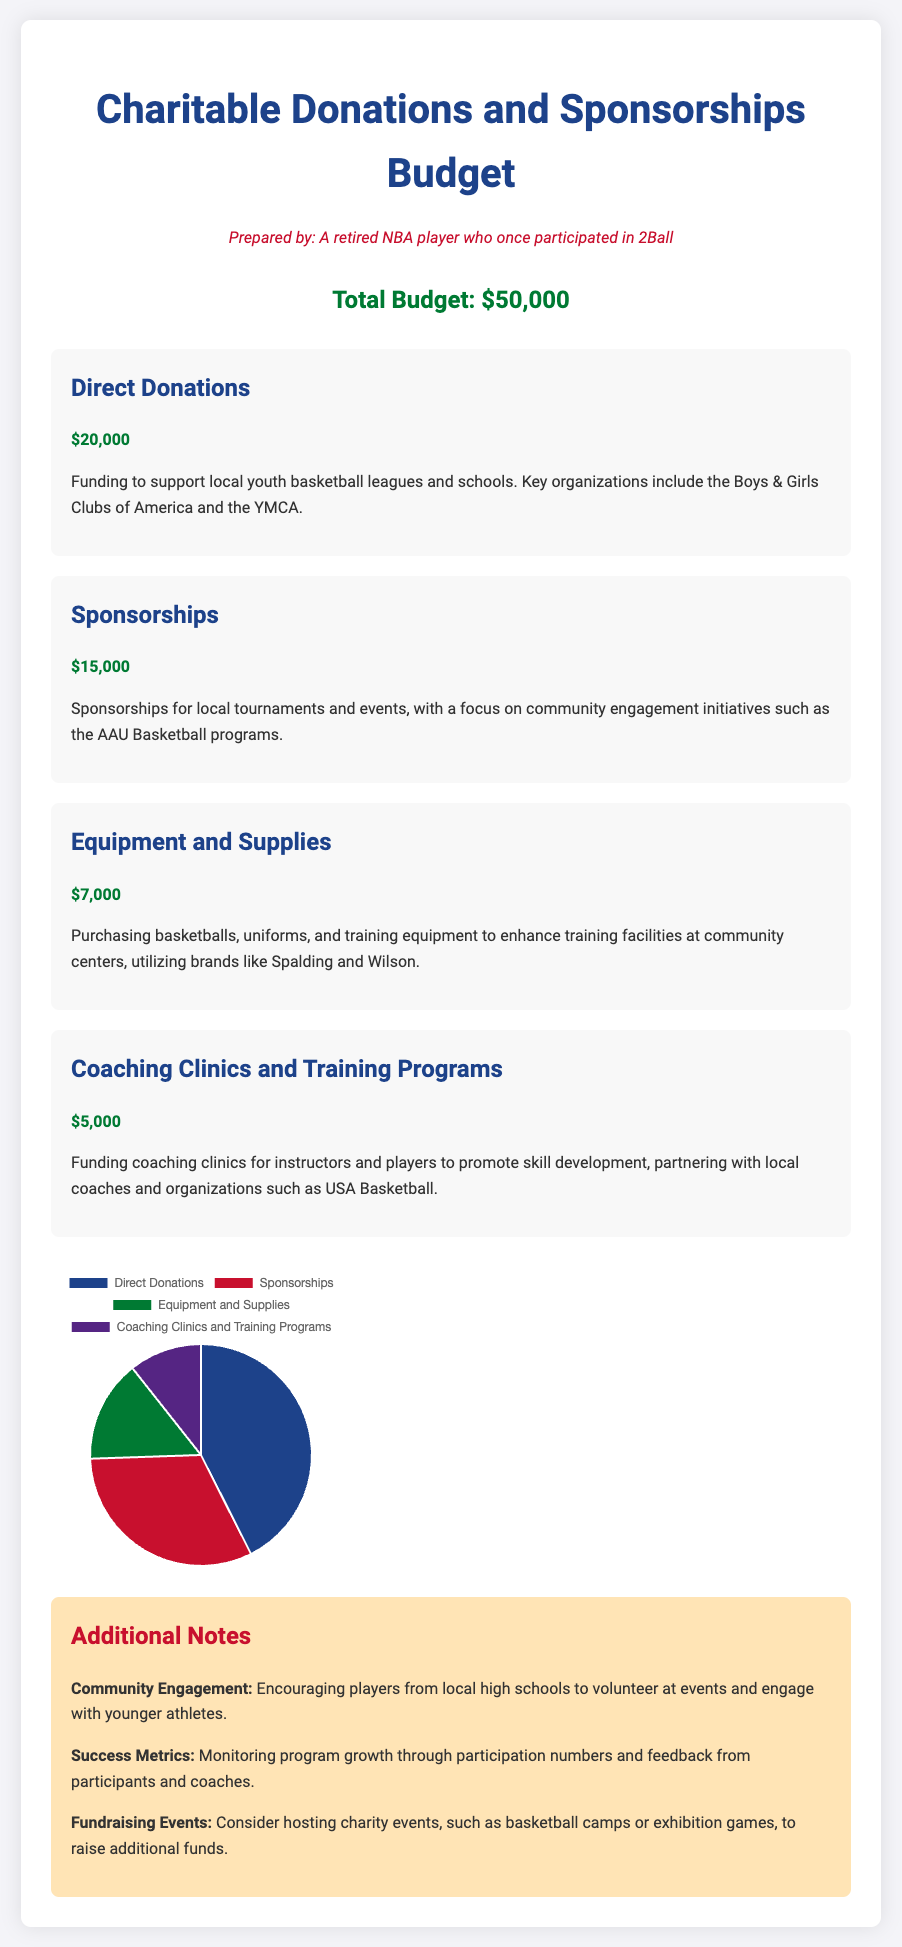What is the total budget? The total budget is explicitly mentioned at the top of the document as $50,000.
Answer: $50,000 How much is allocated for Direct Donations? The amount allocated for Direct Donations is specified in the document as $20,000.
Answer: $20,000 Which organization is mentioned for Direct Donations? The document mentions the Boys & Girls Clubs of America as a key organization for Direct Donations.
Answer: Boys & Girls Clubs of America What percentage of the budget is allocated to Sponsorships? Sponsorships make up $15,000 of the total budget; therefore, it is calculated as (15000 / 50000) * 100 = 30%.
Answer: 30% What is the amount allocated for Equipment and Supplies? The document specifies that $7,000 is allocated for Equipment and Supplies.
Answer: $7,000 What are the success metrics mentioned in the notes? The notes mention monitoring program growth through participation numbers and feedback as success metrics.
Answer: Participation numbers and feedback How much funding is set aside for Coaching Clinics and Training Programs? The allocation for Coaching Clinics and Training Programs is stated as $5,000 in the document.
Answer: $5,000 What is the primary goal of the charitable donations? The document outlines the primary goal as supporting local youth basketball leagues and schools.
Answer: Supporting local youth basketball leagues and schools How much is allocated for equipment purchasing? The document specifies that $7,000 is designated for purchasing basketballs, uniforms, and training equipment.
Answer: $7,000 